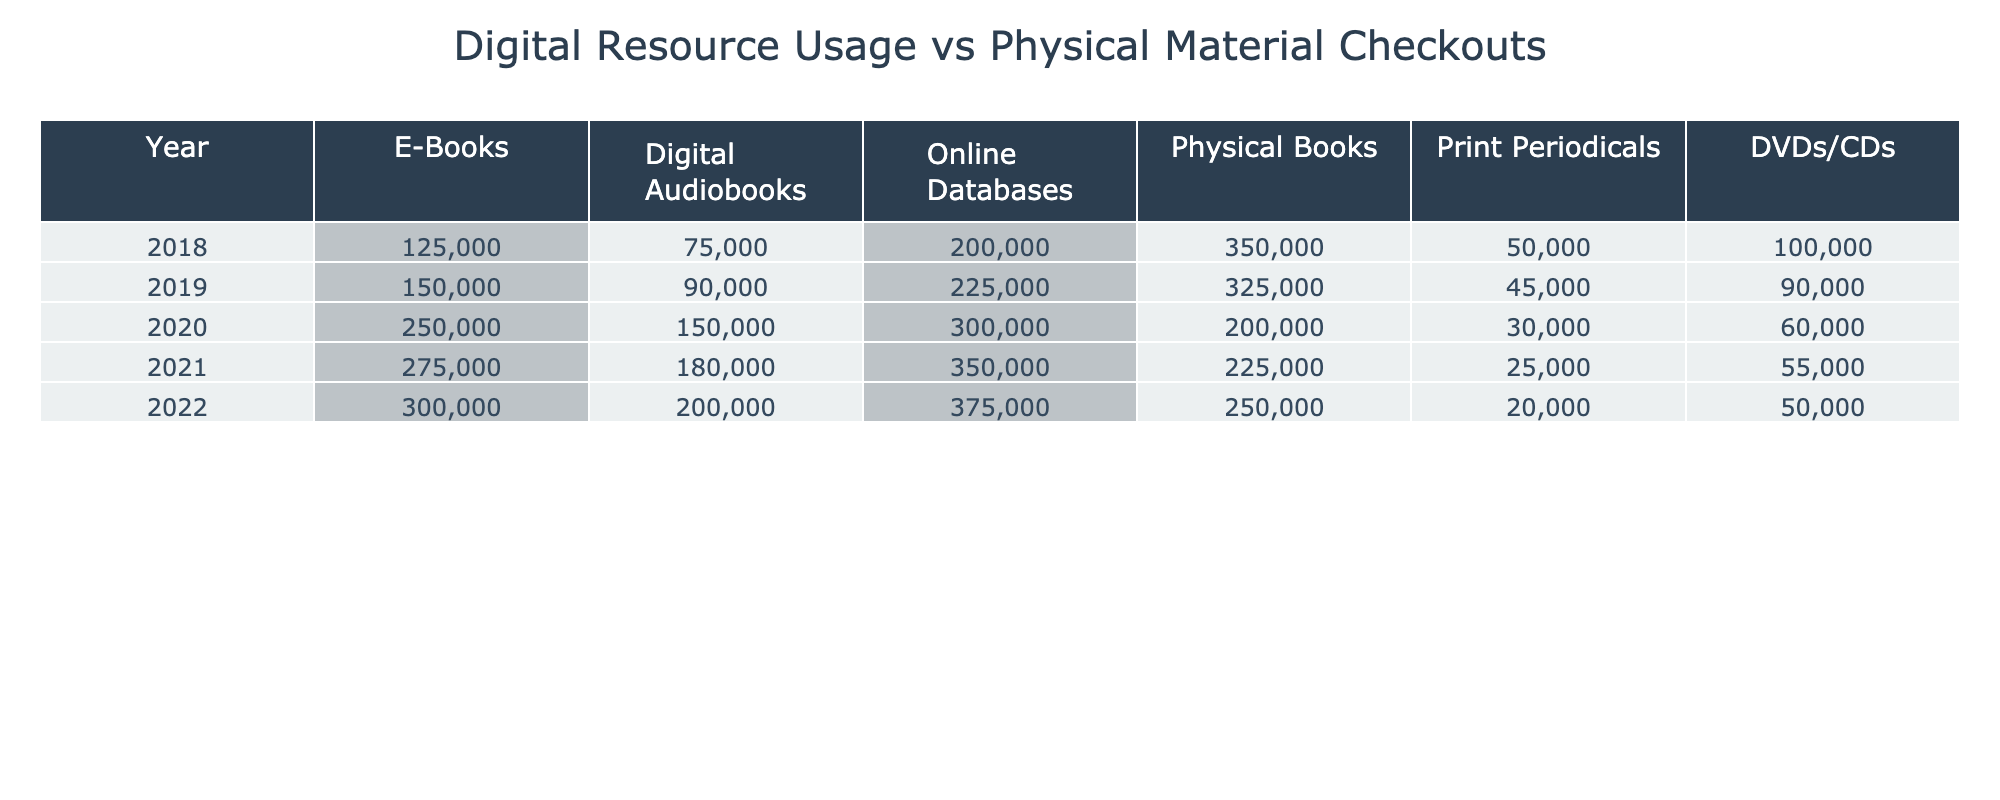What was the number of e-books checked out in 2021? In the table under the "E-Books" column for the year 2021, the value is 275,000.
Answer: 275000 Which year had the highest usage of digital audiobooks? By looking at the "Digital Audiobooks" column, the highest value is 200,000 for the year 2022.
Answer: 2022 How many more physical books were checked out in 2018 compared to 2022? In 2018, physical book checkouts were 350,000 and in 2022 it was 250,000. The difference is 350,000 - 250,000 = 100,000.
Answer: 100000 In which year did online database usage exceed 300,000? By evaluating the "Online Databases" column, the values only exceed 300,000 in the years 2020, 2021, and 2022.
Answer: 2020, 2021, 2022 What is the average number of DVDs/CDs checked out from 2018 to 2022? The values for DVDs/CDs are 100,000, 90,000, 60,000, 55,000, and 50,000. Adding these gives 100,000 + 90,000 + 60,000 + 55,000 + 50,000 = 355,000. Dividing by 5 (number of years) gives 355,000 / 5 = 71,000.
Answer: 71000 Did the usage of e-books increase or decrease from 2019 to 2020? In 2019, the e-book usage was 150,000 and in 2020 it rose to 250,000. Since 250,000 is greater than 150,000, it increased.
Answer: Increase Which digital resource had the largest increment in usage from 2019 to 2020? The increments are: E-Books = 250,000 - 150,000 = 100,000, Digital Audiobooks = 150,000 - 90,000 = 60,000, Online Databases = 300,000 - 225,000 = 75,000. The largest increment is for E-Books at 100,000.
Answer: E-Books How many total physical materials were checked out in 2020? The total physical materials for 2020 include Physical Books (200,000), Print Periodicals (30,000), and DVDs/CDs (60,000), giving 200,000 + 30,000 + 60,000 = 290,000.
Answer: 290000 Is the combined total of e-books and digital audiobooks greater in 2021 than in 2019? In 2021, the total for e-books and digital audiobooks is 275,000 + 180,000 = 455,000. In 2019, the total is 150,000 + 90,000 = 240,000. Since 455,000 is greater than 240,000, the answer is yes.
Answer: Yes What is the trend for print periodicals from 2018 to 2022? The values for print periodicals over these years are: 50,000 (2018), 45,000 (2019), 30,000 (2020), 25,000 (2021), and 20,000 (2022). It shows a decreasing trend year over year.
Answer: Decreasing 